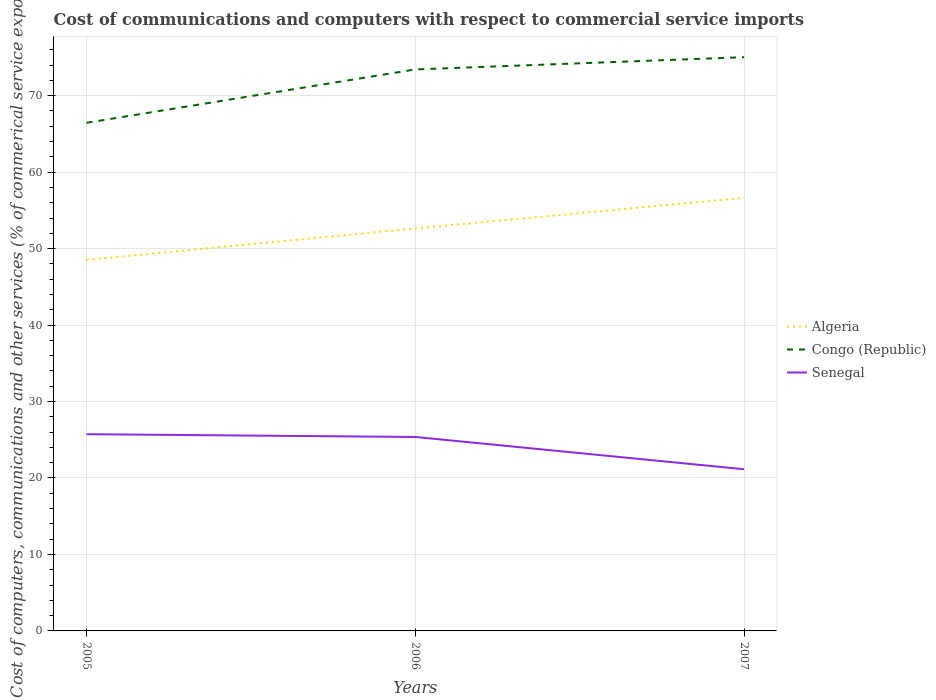Across all years, what is the maximum cost of communications and computers in Senegal?
Give a very brief answer. 21.14. What is the total cost of communications and computers in Senegal in the graph?
Your answer should be very brief. 0.36. What is the difference between the highest and the second highest cost of communications and computers in Senegal?
Make the answer very short. 4.59. How many lines are there?
Provide a short and direct response. 3. How many legend labels are there?
Your answer should be very brief. 3. How are the legend labels stacked?
Your response must be concise. Vertical. What is the title of the graph?
Your response must be concise. Cost of communications and computers with respect to commercial service imports. Does "Dominican Republic" appear as one of the legend labels in the graph?
Make the answer very short. No. What is the label or title of the Y-axis?
Ensure brevity in your answer.  Cost of computers, communications and other services (% of commerical service exports). What is the Cost of computers, communications and other services (% of commerical service exports) in Algeria in 2005?
Your answer should be compact. 48.52. What is the Cost of computers, communications and other services (% of commerical service exports) of Congo (Republic) in 2005?
Your answer should be very brief. 66.45. What is the Cost of computers, communications and other services (% of commerical service exports) of Senegal in 2005?
Your response must be concise. 25.73. What is the Cost of computers, communications and other services (% of commerical service exports) of Algeria in 2006?
Your answer should be compact. 52.64. What is the Cost of computers, communications and other services (% of commerical service exports) of Congo (Republic) in 2006?
Give a very brief answer. 73.43. What is the Cost of computers, communications and other services (% of commerical service exports) in Senegal in 2006?
Offer a terse response. 25.37. What is the Cost of computers, communications and other services (% of commerical service exports) in Algeria in 2007?
Make the answer very short. 56.64. What is the Cost of computers, communications and other services (% of commerical service exports) in Congo (Republic) in 2007?
Offer a terse response. 75.03. What is the Cost of computers, communications and other services (% of commerical service exports) in Senegal in 2007?
Give a very brief answer. 21.14. Across all years, what is the maximum Cost of computers, communications and other services (% of commerical service exports) in Algeria?
Provide a short and direct response. 56.64. Across all years, what is the maximum Cost of computers, communications and other services (% of commerical service exports) of Congo (Republic)?
Provide a short and direct response. 75.03. Across all years, what is the maximum Cost of computers, communications and other services (% of commerical service exports) of Senegal?
Your answer should be compact. 25.73. Across all years, what is the minimum Cost of computers, communications and other services (% of commerical service exports) in Algeria?
Provide a short and direct response. 48.52. Across all years, what is the minimum Cost of computers, communications and other services (% of commerical service exports) of Congo (Republic)?
Provide a succinct answer. 66.45. Across all years, what is the minimum Cost of computers, communications and other services (% of commerical service exports) in Senegal?
Your answer should be compact. 21.14. What is the total Cost of computers, communications and other services (% of commerical service exports) of Algeria in the graph?
Offer a very short reply. 157.8. What is the total Cost of computers, communications and other services (% of commerical service exports) in Congo (Republic) in the graph?
Keep it short and to the point. 214.92. What is the total Cost of computers, communications and other services (% of commerical service exports) in Senegal in the graph?
Keep it short and to the point. 72.24. What is the difference between the Cost of computers, communications and other services (% of commerical service exports) in Algeria in 2005 and that in 2006?
Your answer should be compact. -4.11. What is the difference between the Cost of computers, communications and other services (% of commerical service exports) in Congo (Republic) in 2005 and that in 2006?
Your answer should be compact. -6.98. What is the difference between the Cost of computers, communications and other services (% of commerical service exports) in Senegal in 2005 and that in 2006?
Offer a very short reply. 0.36. What is the difference between the Cost of computers, communications and other services (% of commerical service exports) in Algeria in 2005 and that in 2007?
Your answer should be compact. -8.11. What is the difference between the Cost of computers, communications and other services (% of commerical service exports) of Congo (Republic) in 2005 and that in 2007?
Offer a very short reply. -8.58. What is the difference between the Cost of computers, communications and other services (% of commerical service exports) of Senegal in 2005 and that in 2007?
Give a very brief answer. 4.59. What is the difference between the Cost of computers, communications and other services (% of commerical service exports) of Algeria in 2006 and that in 2007?
Provide a succinct answer. -4. What is the difference between the Cost of computers, communications and other services (% of commerical service exports) of Congo (Republic) in 2006 and that in 2007?
Your answer should be compact. -1.6. What is the difference between the Cost of computers, communications and other services (% of commerical service exports) of Senegal in 2006 and that in 2007?
Your answer should be very brief. 4.22. What is the difference between the Cost of computers, communications and other services (% of commerical service exports) of Algeria in 2005 and the Cost of computers, communications and other services (% of commerical service exports) of Congo (Republic) in 2006?
Your answer should be compact. -24.91. What is the difference between the Cost of computers, communications and other services (% of commerical service exports) in Algeria in 2005 and the Cost of computers, communications and other services (% of commerical service exports) in Senegal in 2006?
Your answer should be very brief. 23.16. What is the difference between the Cost of computers, communications and other services (% of commerical service exports) in Congo (Republic) in 2005 and the Cost of computers, communications and other services (% of commerical service exports) in Senegal in 2006?
Make the answer very short. 41.09. What is the difference between the Cost of computers, communications and other services (% of commerical service exports) of Algeria in 2005 and the Cost of computers, communications and other services (% of commerical service exports) of Congo (Republic) in 2007?
Offer a terse response. -26.51. What is the difference between the Cost of computers, communications and other services (% of commerical service exports) of Algeria in 2005 and the Cost of computers, communications and other services (% of commerical service exports) of Senegal in 2007?
Offer a terse response. 27.38. What is the difference between the Cost of computers, communications and other services (% of commerical service exports) in Congo (Republic) in 2005 and the Cost of computers, communications and other services (% of commerical service exports) in Senegal in 2007?
Offer a terse response. 45.31. What is the difference between the Cost of computers, communications and other services (% of commerical service exports) in Algeria in 2006 and the Cost of computers, communications and other services (% of commerical service exports) in Congo (Republic) in 2007?
Keep it short and to the point. -22.4. What is the difference between the Cost of computers, communications and other services (% of commerical service exports) of Algeria in 2006 and the Cost of computers, communications and other services (% of commerical service exports) of Senegal in 2007?
Provide a succinct answer. 31.49. What is the difference between the Cost of computers, communications and other services (% of commerical service exports) of Congo (Republic) in 2006 and the Cost of computers, communications and other services (% of commerical service exports) of Senegal in 2007?
Ensure brevity in your answer.  52.29. What is the average Cost of computers, communications and other services (% of commerical service exports) of Algeria per year?
Offer a very short reply. 52.6. What is the average Cost of computers, communications and other services (% of commerical service exports) of Congo (Republic) per year?
Your answer should be very brief. 71.64. What is the average Cost of computers, communications and other services (% of commerical service exports) in Senegal per year?
Provide a short and direct response. 24.08. In the year 2005, what is the difference between the Cost of computers, communications and other services (% of commerical service exports) in Algeria and Cost of computers, communications and other services (% of commerical service exports) in Congo (Republic)?
Make the answer very short. -17.93. In the year 2005, what is the difference between the Cost of computers, communications and other services (% of commerical service exports) in Algeria and Cost of computers, communications and other services (% of commerical service exports) in Senegal?
Offer a very short reply. 22.8. In the year 2005, what is the difference between the Cost of computers, communications and other services (% of commerical service exports) in Congo (Republic) and Cost of computers, communications and other services (% of commerical service exports) in Senegal?
Your response must be concise. 40.72. In the year 2006, what is the difference between the Cost of computers, communications and other services (% of commerical service exports) of Algeria and Cost of computers, communications and other services (% of commerical service exports) of Congo (Republic)?
Give a very brief answer. -20.8. In the year 2006, what is the difference between the Cost of computers, communications and other services (% of commerical service exports) in Algeria and Cost of computers, communications and other services (% of commerical service exports) in Senegal?
Keep it short and to the point. 27.27. In the year 2006, what is the difference between the Cost of computers, communications and other services (% of commerical service exports) of Congo (Republic) and Cost of computers, communications and other services (% of commerical service exports) of Senegal?
Your answer should be compact. 48.07. In the year 2007, what is the difference between the Cost of computers, communications and other services (% of commerical service exports) in Algeria and Cost of computers, communications and other services (% of commerical service exports) in Congo (Republic)?
Ensure brevity in your answer.  -18.4. In the year 2007, what is the difference between the Cost of computers, communications and other services (% of commerical service exports) in Algeria and Cost of computers, communications and other services (% of commerical service exports) in Senegal?
Give a very brief answer. 35.49. In the year 2007, what is the difference between the Cost of computers, communications and other services (% of commerical service exports) of Congo (Republic) and Cost of computers, communications and other services (% of commerical service exports) of Senegal?
Keep it short and to the point. 53.89. What is the ratio of the Cost of computers, communications and other services (% of commerical service exports) of Algeria in 2005 to that in 2006?
Provide a short and direct response. 0.92. What is the ratio of the Cost of computers, communications and other services (% of commerical service exports) in Congo (Republic) in 2005 to that in 2006?
Your answer should be compact. 0.9. What is the ratio of the Cost of computers, communications and other services (% of commerical service exports) in Senegal in 2005 to that in 2006?
Keep it short and to the point. 1.01. What is the ratio of the Cost of computers, communications and other services (% of commerical service exports) of Algeria in 2005 to that in 2007?
Offer a terse response. 0.86. What is the ratio of the Cost of computers, communications and other services (% of commerical service exports) in Congo (Republic) in 2005 to that in 2007?
Provide a short and direct response. 0.89. What is the ratio of the Cost of computers, communications and other services (% of commerical service exports) of Senegal in 2005 to that in 2007?
Offer a very short reply. 1.22. What is the ratio of the Cost of computers, communications and other services (% of commerical service exports) in Algeria in 2006 to that in 2007?
Offer a very short reply. 0.93. What is the ratio of the Cost of computers, communications and other services (% of commerical service exports) in Congo (Republic) in 2006 to that in 2007?
Keep it short and to the point. 0.98. What is the ratio of the Cost of computers, communications and other services (% of commerical service exports) in Senegal in 2006 to that in 2007?
Offer a very short reply. 1.2. What is the difference between the highest and the second highest Cost of computers, communications and other services (% of commerical service exports) in Algeria?
Your response must be concise. 4. What is the difference between the highest and the second highest Cost of computers, communications and other services (% of commerical service exports) of Congo (Republic)?
Make the answer very short. 1.6. What is the difference between the highest and the second highest Cost of computers, communications and other services (% of commerical service exports) in Senegal?
Offer a very short reply. 0.36. What is the difference between the highest and the lowest Cost of computers, communications and other services (% of commerical service exports) in Algeria?
Ensure brevity in your answer.  8.11. What is the difference between the highest and the lowest Cost of computers, communications and other services (% of commerical service exports) in Congo (Republic)?
Your answer should be compact. 8.58. What is the difference between the highest and the lowest Cost of computers, communications and other services (% of commerical service exports) of Senegal?
Your answer should be compact. 4.59. 